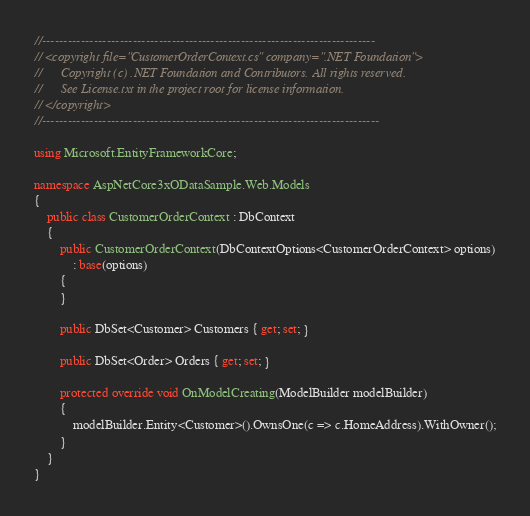Convert code to text. <code><loc_0><loc_0><loc_500><loc_500><_C#_>//-----------------------------------------------------------------------------
// <copyright file="CustomerOrderContext.cs" company=".NET Foundation">
//      Copyright (c) .NET Foundation and Contributors. All rights reserved. 
//      See License.txt in the project root for license information.
// </copyright>
//------------------------------------------------------------------------------

using Microsoft.EntityFrameworkCore;

namespace AspNetCore3xODataSample.Web.Models
{
    public class CustomerOrderContext : DbContext
    {
        public CustomerOrderContext(DbContextOptions<CustomerOrderContext> options)
            : base(options)
        {
        }

        public DbSet<Customer> Customers { get; set; }

        public DbSet<Order> Orders { get; set; }

        protected override void OnModelCreating(ModelBuilder modelBuilder)
        {
            modelBuilder.Entity<Customer>().OwnsOne(c => c.HomeAddress).WithOwner();
        }
    }
}
</code> 